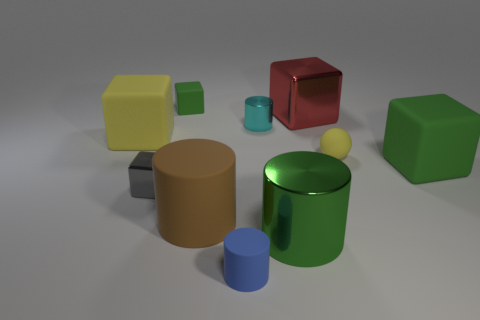Subtract all small metal cylinders. How many cylinders are left? 3 Subtract 3 cylinders. How many cylinders are left? 1 Subtract all green blocks. How many blocks are left? 3 Subtract all red cylinders. How many cyan spheres are left? 0 Subtract all yellow rubber balls. Subtract all cyan cylinders. How many objects are left? 8 Add 4 small blue matte objects. How many small blue matte objects are left? 5 Add 8 green metal balls. How many green metal balls exist? 8 Subtract 1 cyan cylinders. How many objects are left? 9 Subtract all balls. How many objects are left? 9 Subtract all gray cubes. Subtract all yellow cylinders. How many cubes are left? 4 